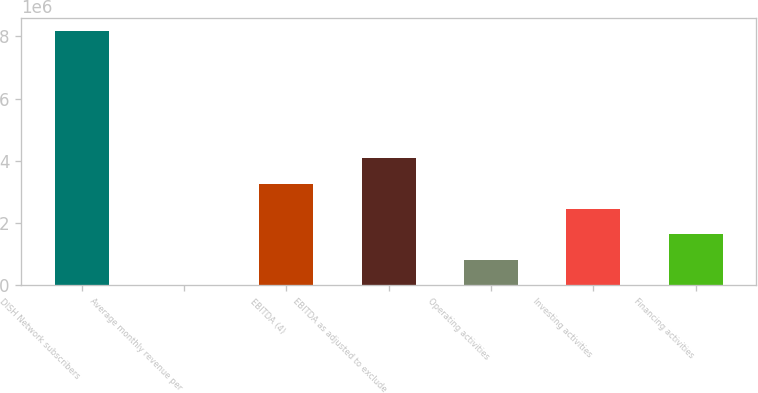Convert chart to OTSL. <chart><loc_0><loc_0><loc_500><loc_500><bar_chart><fcel>DISH Network subscribers<fcel>Average monthly revenue per<fcel>EBITDA (4)<fcel>EBITDA as adjusted to exclude<fcel>Operating activities<fcel>Investing activities<fcel>Financing activities<nl><fcel>8.18e+06<fcel>49.17<fcel>3.27203e+06<fcel>4.09002e+06<fcel>818044<fcel>2.45403e+06<fcel>1.63604e+06<nl></chart> 